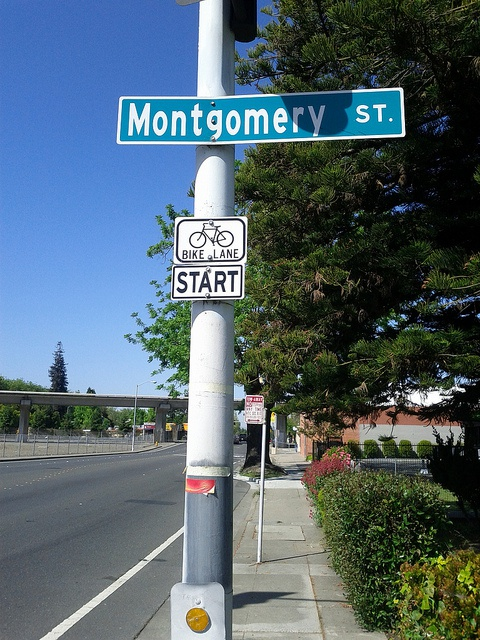Describe the objects in this image and their specific colors. I can see a bicycle in gray, white, black, and darkgray tones in this image. 